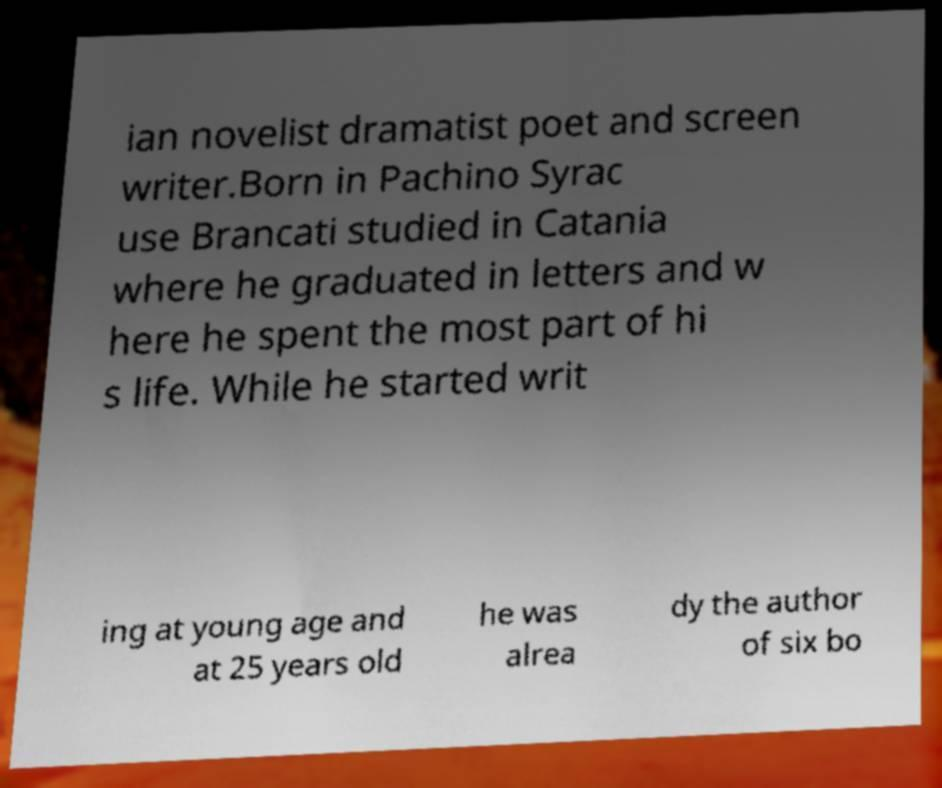I need the written content from this picture converted into text. Can you do that? ian novelist dramatist poet and screen writer.Born in Pachino Syrac use Brancati studied in Catania where he graduated in letters and w here he spent the most part of hi s life. While he started writ ing at young age and at 25 years old he was alrea dy the author of six bo 